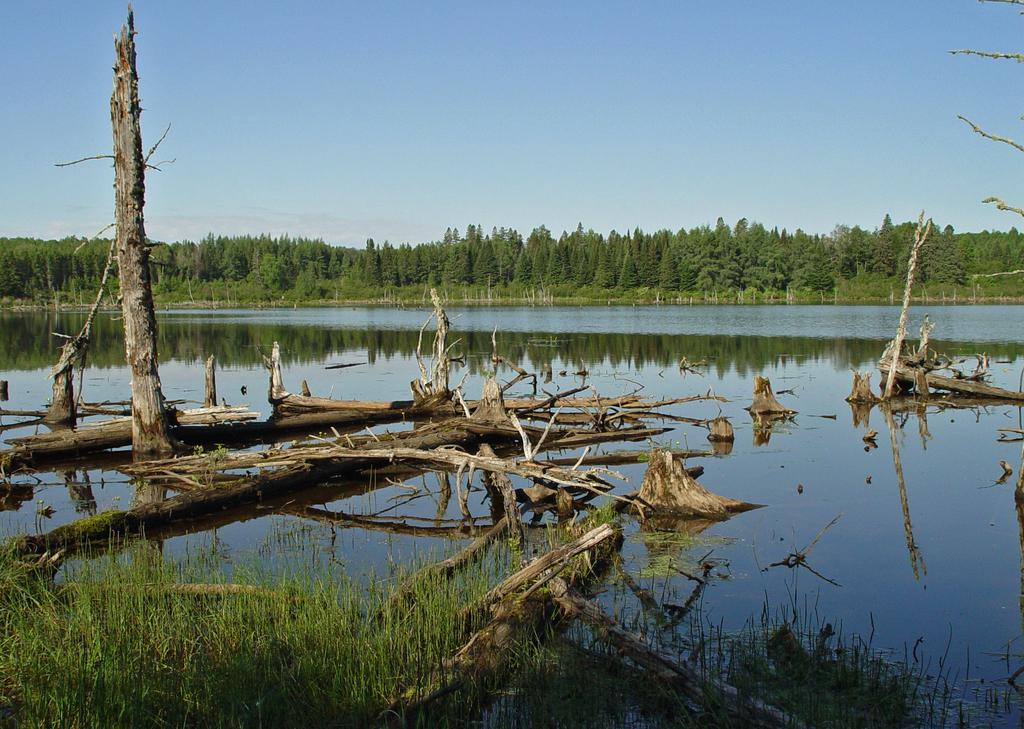What is floating on the surface of the water in the image? There are wooden logs on the surface of the water in the image. What can be seen in the background of the image? There are trees in the background of the image. What is visible at the top of the image? The sky is visible at the top of the image. How many cacti can be seen in the image? There are no cacti present in the image; it features wooden logs on the water and trees in the background. Are the sisters playing near the wooden logs in the image? There is no mention of sisters in the image, and the focus is on the wooden logs and the surrounding environment. 